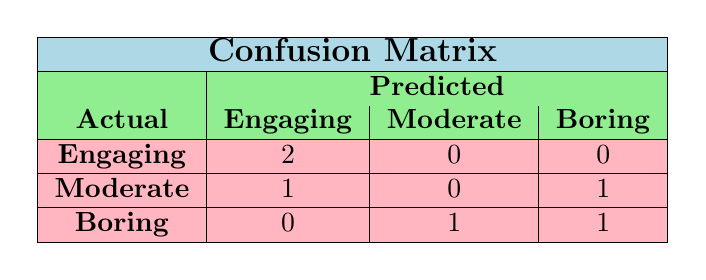What is the total number of speakers classified as engaging? By looking at the first row of the table, we see that there are 2 instances of speakers classified as engaging under the actual classification. Therefore, the total number of speakers classified as engaging is 2.
Answer: 2 How many speakers were predicted to be boring? In the last column of the table under the predicted classification, there are 2 instances of speakers classified as boring (one from the last row and another from the row of moderate). Thus, the total number of speakers predicted to be boring is 2.
Answer: 2 Is it true that all speakers in the engaging category were predicted correctly? In the first row of the table, both instances of engaging speakers (Michael Johnson and Emma Davis) were predicted correctly as engaging. Thus, it is true that all speakers in the engaging category were predicted correctly.
Answer: Yes What is the difference in the number of moderate predictions versus boring predictions? The number of speakers predicted as moderate is 1, and the number of speakers predicted as boring is 2. The difference is calculated as 2 (boring) - 1 (moderate) = 1.
Answer: 1 How many speakers were classified as moderate in both actual and predicted classifications? Looking at the table, in the actual classification, there is 1 speaker (Sarah Patel) and in the predicted classification also 0 speakers were predicted as moderate. Hence, the number of speakers classified as moderate in both classifications is 1.
Answer: 0 What is the proportion of speakers predicted as engaging to those classified as boring? There are 2 speakers predicted as engaging and 2 speakers classified as boring. The proportion is calculated as 2 (engaging) / 2 (boring) = 1.
Answer: 1 How many speakers predicted the actual category of boring while being classified as moderate? Referring to the table, we see that only 1 speaker predicted boring while their actual classification was moderate (James Smith). Thus, there is only one such speaker.
Answer: 1 What percentage of total speakers were accurately predicted as either engaging or boring? We have a total of 6 speakers. Only 4 were accurately predicted (2 engaging + 2 boring out of 2 engaging and 2 boring). To find the percentage, we calculate (4 / 6) * 100 = 66.67%.
Answer: 66.67% 